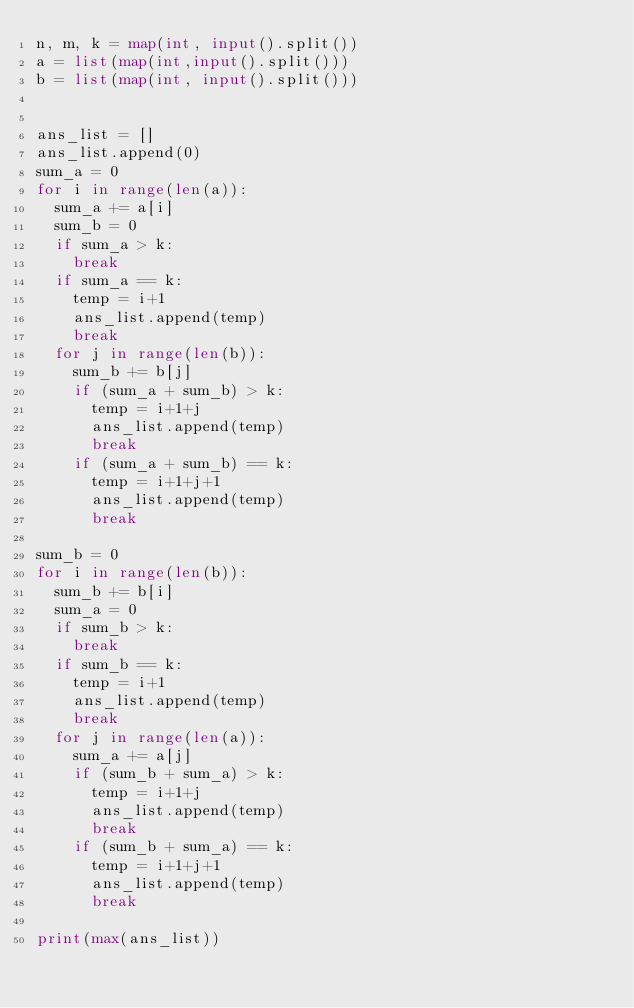Convert code to text. <code><loc_0><loc_0><loc_500><loc_500><_Python_>n, m, k = map(int, input().split())
a = list(map(int,input().split()))
b = list(map(int, input().split()))


ans_list = []
ans_list.append(0)
sum_a = 0
for i in range(len(a)):
  sum_a += a[i]
  sum_b = 0
  if sum_a > k:
    break
  if sum_a == k:
    temp = i+1
    ans_list.append(temp)
    break
  for j in range(len(b)):
    sum_b += b[j]
    if (sum_a + sum_b) > k:
      temp = i+1+j
      ans_list.append(temp)
      break
    if (sum_a + sum_b) == k:
      temp = i+1+j+1
      ans_list.append(temp)
      break
      
sum_b = 0
for i in range(len(b)):
  sum_b += b[i]
  sum_a = 0
  if sum_b > k:
    break
  if sum_b == k:
    temp = i+1
    ans_list.append(temp)
    break
  for j in range(len(a)):
    sum_a += a[j]
    if (sum_b + sum_a) > k:
      temp = i+1+j
      ans_list.append(temp)
      break
    if (sum_b + sum_a) == k:
      temp = i+1+j+1
      ans_list.append(temp)
      break
      
print(max(ans_list))</code> 